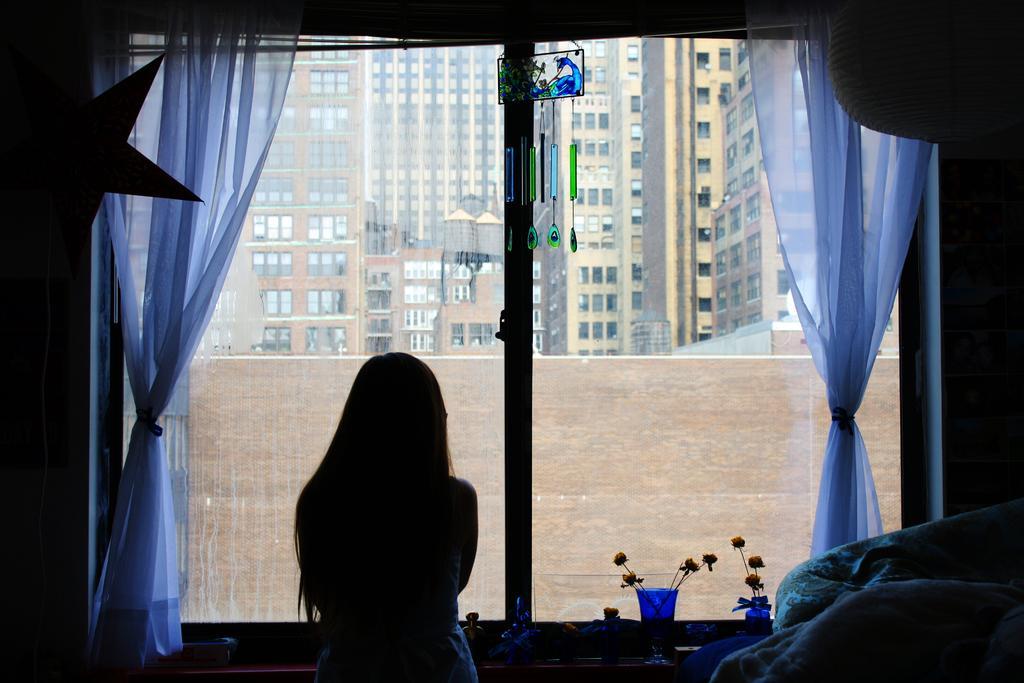Describe this image in one or two sentences. In this image I can see the person standing and I can see few flowers in the glasses, few curtains and the window. In the background I can see few buildings. 